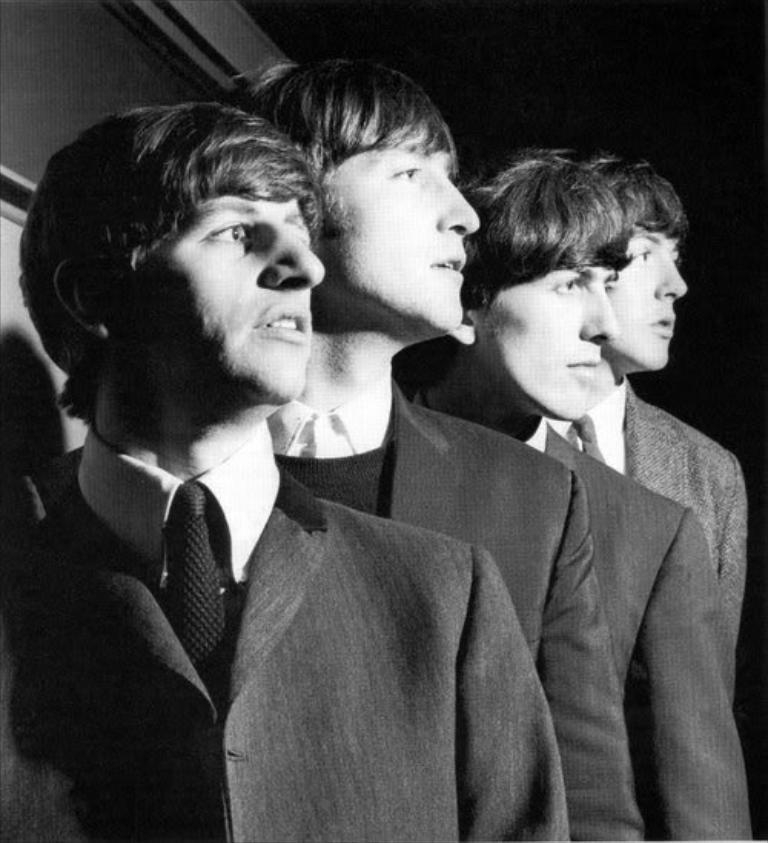How many people are in the image? There are four men in the image. What are the men wearing in the image? Each man is wearing a suit and a tie. What can be observed about the background of the image? The background of the image is dark. What type of weather can be seen in the image? There is no weather visible in the image, as it is focused on the four men and their attire. What is the yoke used for in the image? There is no yoke present in the image. 